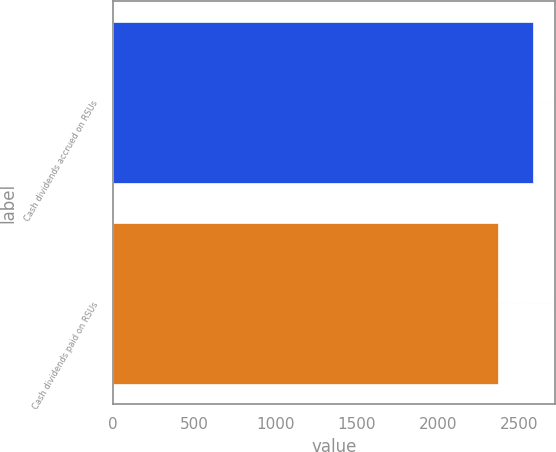Convert chart. <chart><loc_0><loc_0><loc_500><loc_500><bar_chart><fcel>Cash dividends accrued on RSUs<fcel>Cash dividends paid on RSUs<nl><fcel>2590<fcel>2370<nl></chart> 